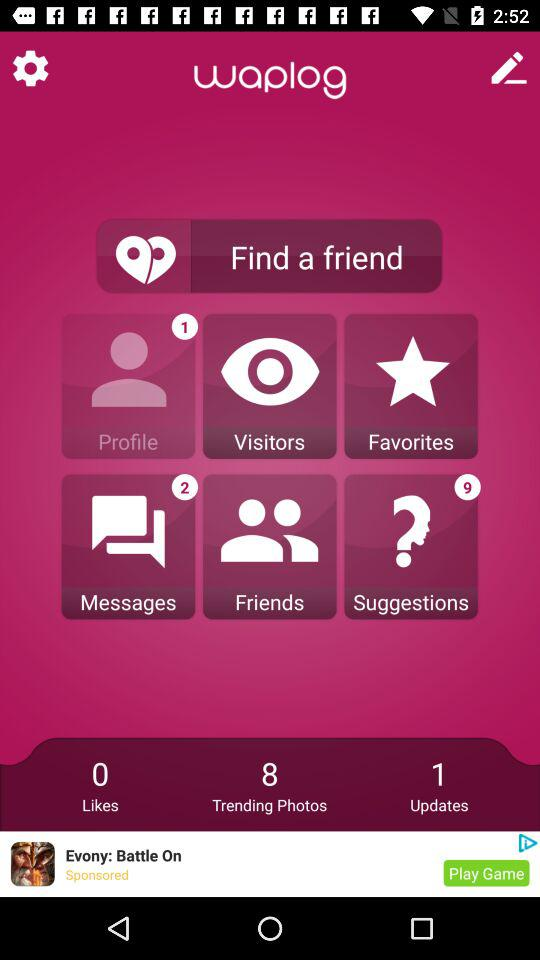How many likes are shown on the screen? There are 0 likes shown on the screen. 